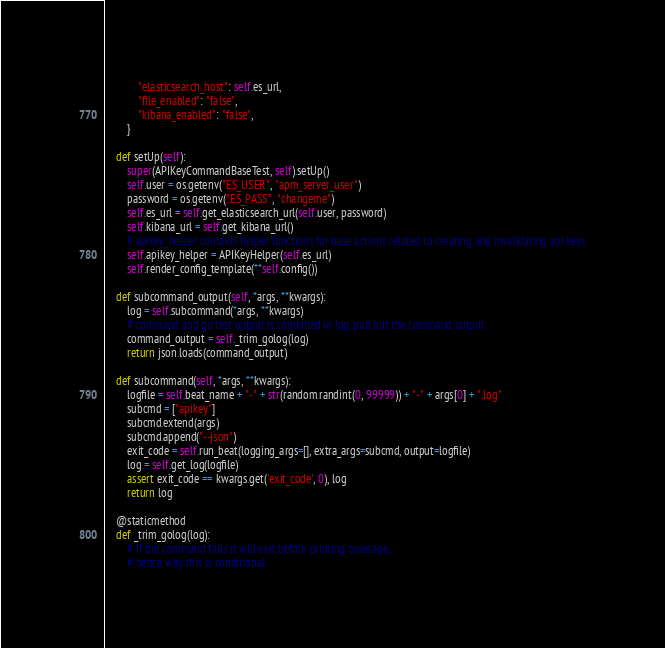<code> <loc_0><loc_0><loc_500><loc_500><_Python_>            "elasticsearch_host": self.es_url,
            "file_enabled": "false",
            "kibana_enabled": "false",
        }

    def setUp(self):
        super(APIKeyCommandBaseTest, self).setUp()
        self.user = os.getenv("ES_USER", "apm_server_user")
        password = os.getenv("ES_PASS", "changeme")
        self.es_url = self.get_elasticsearch_url(self.user, password)
        self.kibana_url = self.get_kibana_url()
        # apikey_helper contains helper functions for base actions related to creating and invalidating api keys
        self.apikey_helper = APIKeyHelper(self.es_url)
        self.render_config_template(**self.config())

    def subcommand_output(self, *args, **kwargs):
        log = self.subcommand(*args, **kwargs)
        # command and go test output is combined in log, pull out the command output
        command_output = self._trim_golog(log)
        return json.loads(command_output)

    def subcommand(self, *args, **kwargs):
        logfile = self.beat_name + "-" + str(random.randint(0, 99999)) + "-" + args[0] + ".log"
        subcmd = ["apikey"]
        subcmd.extend(args)
        subcmd.append("--json")
        exit_code = self.run_beat(logging_args=[], extra_args=subcmd, output=logfile)
        log = self.get_log(logfile)
        assert exit_code == kwargs.get('exit_code', 0), log
        return log

    @staticmethod
    def _trim_golog(log):
        # If the command fails it will exit before printing coverage,
        # hence why this is conditional.</code> 